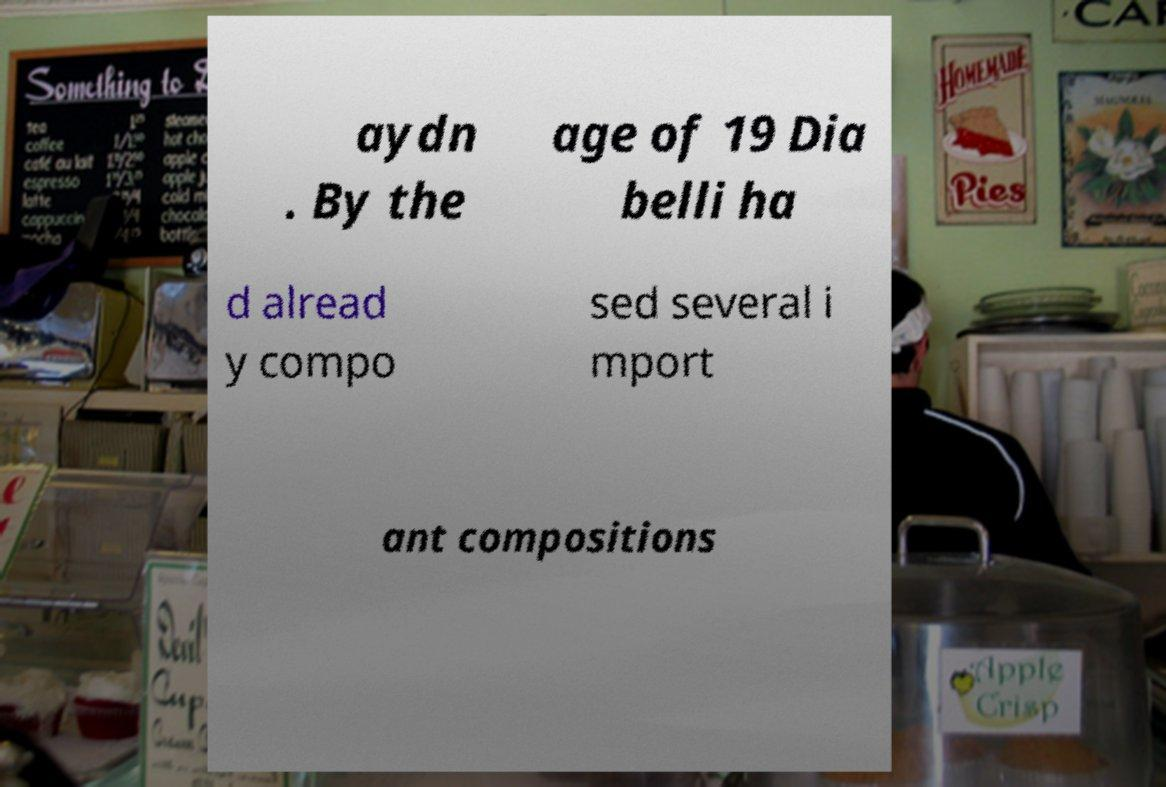What messages or text are displayed in this image? I need them in a readable, typed format. aydn . By the age of 19 Dia belli ha d alread y compo sed several i mport ant compositions 